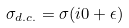<formula> <loc_0><loc_0><loc_500><loc_500>\sigma _ { d . c . } = \sigma ( i 0 + \epsilon )</formula> 